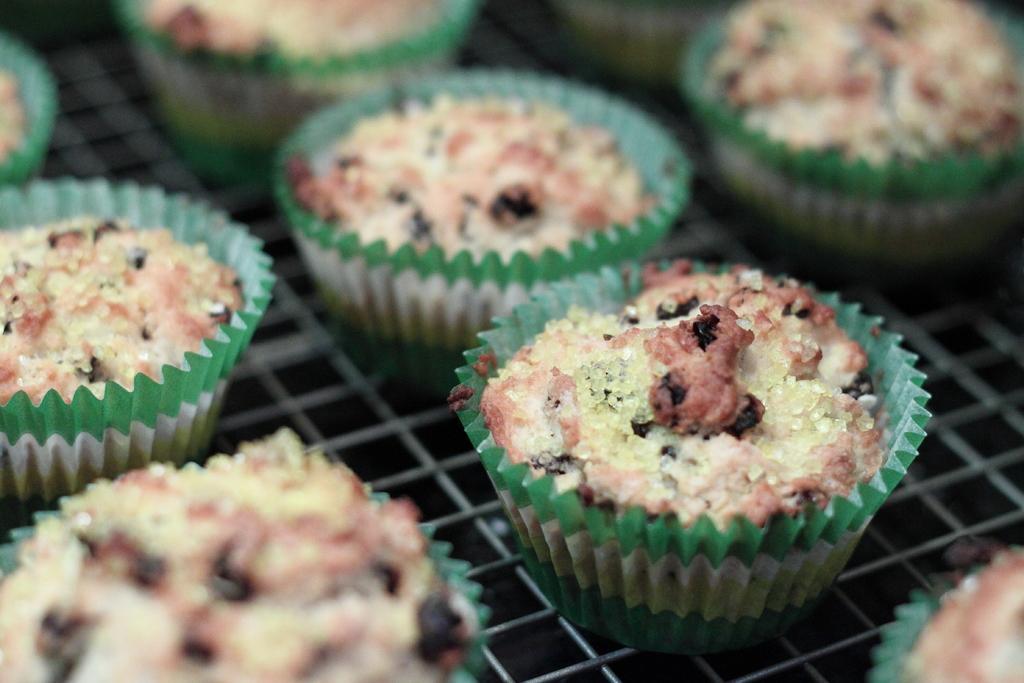Can you describe this image briefly? In the picture I can see few cupcakes placed on an object. 